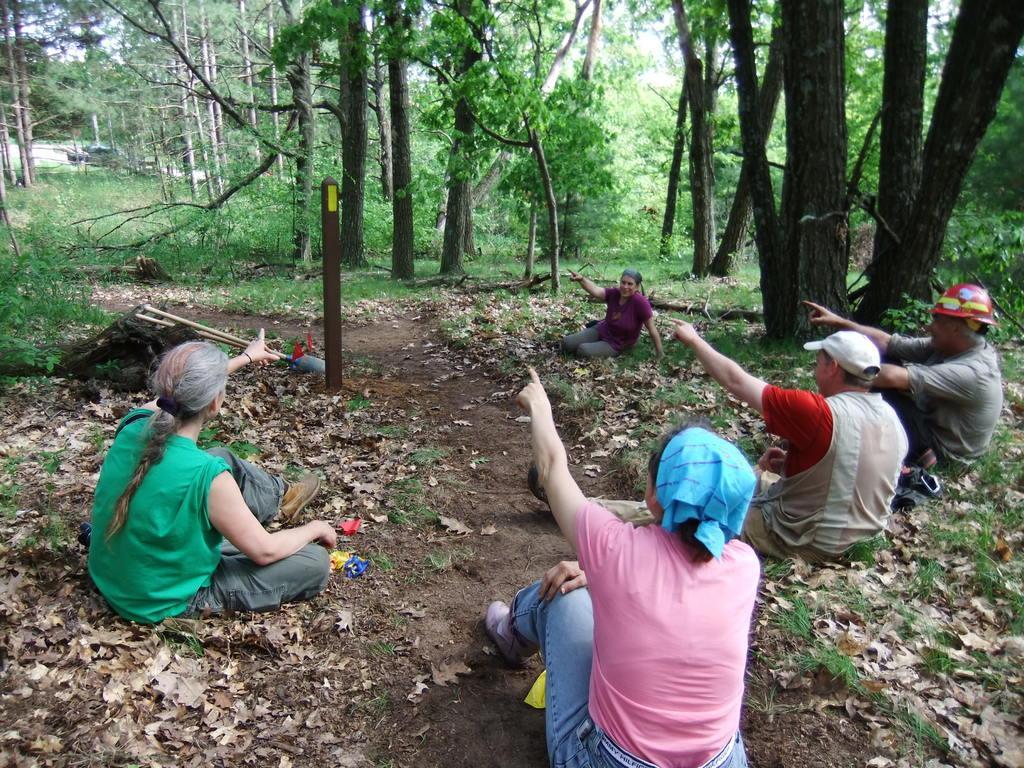Please provide a concise description of this image. In this image we can see a few people sitting, near that we can see pole, after that we can see grass and dried leaves, we can see trees and plants, at the top we can see the sky. 